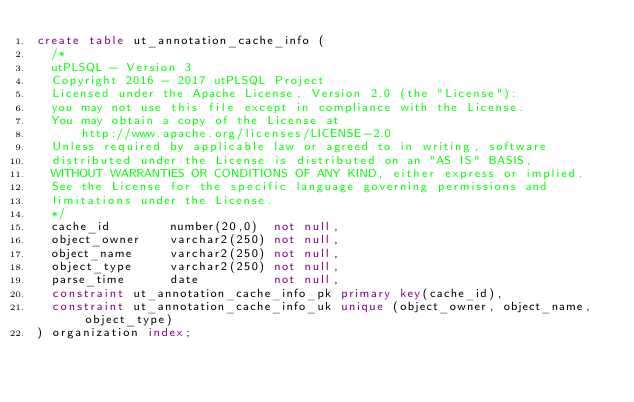<code> <loc_0><loc_0><loc_500><loc_500><_SQL_>create table ut_annotation_cache_info (
  /*
  utPLSQL - Version 3
  Copyright 2016 - 2017 utPLSQL Project
  Licensed under the Apache License, Version 2.0 (the "License"):
  you may not use this file except in compliance with the License.
  You may obtain a copy of the License at
      http://www.apache.org/licenses/LICENSE-2.0
  Unless required by applicable law or agreed to in writing, software
  distributed under the License is distributed on an "AS IS" BASIS,
  WITHOUT WARRANTIES OR CONDITIONS OF ANY KIND, either express or implied.
  See the License for the specific language governing permissions and
  limitations under the License.
  */
  cache_id        number(20,0)  not null,
  object_owner    varchar2(250) not null,
  object_name     varchar2(250) not null,
  object_type     varchar2(250) not null,
  parse_time      date          not null,
  constraint ut_annotation_cache_info_pk primary key(cache_id),
  constraint ut_annotation_cache_info_uk unique (object_owner, object_name, object_type)
) organization index;

</code> 